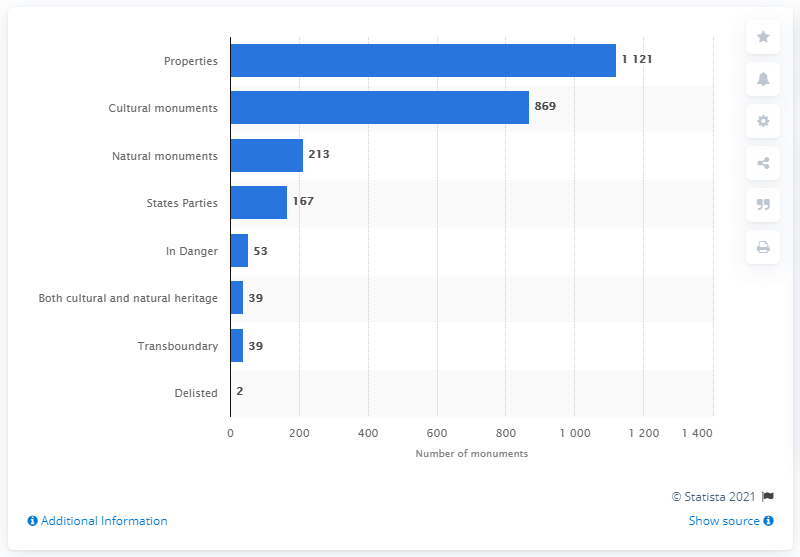Give some essential details in this illustration. As of the current count, there are 213 natural monuments on the United Nations Educational, Scientific and Cultural Organization (UNESCO) World Heritage List. There are currently 869 cultural monuments listed on the UNESCO World Heritage list. 